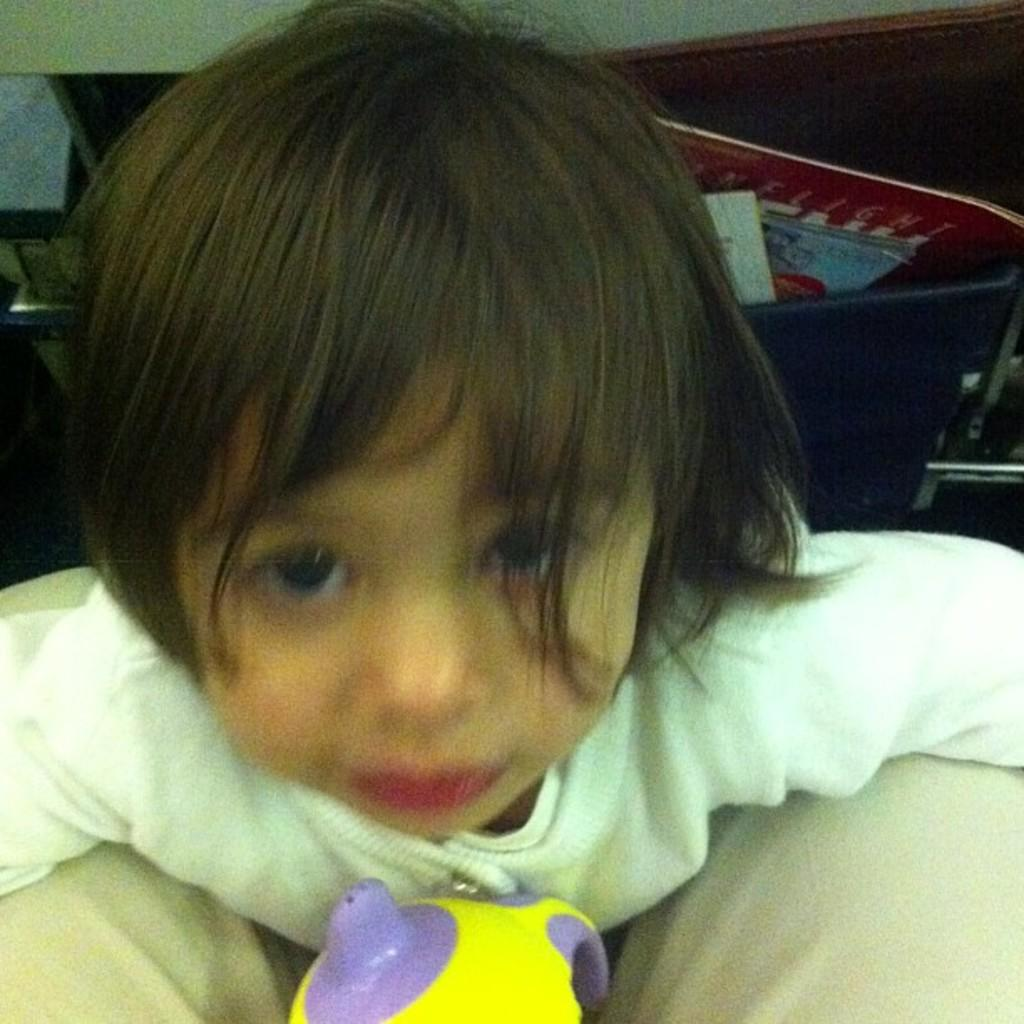Who is the main subject in the image? There is a girl in the image. What is located in front of the girl? There is a toy in front of the girl. What can be seen in the background of the image? There is a book in the background of the image. Are there any other objects visible in the background? Yes, there are other objects visible in the background of the image. What type of plastic material is the girl using to lift the toy in the image? There is no plastic material or lifting action depicted in the image; the girl is simply standing near a toy. 